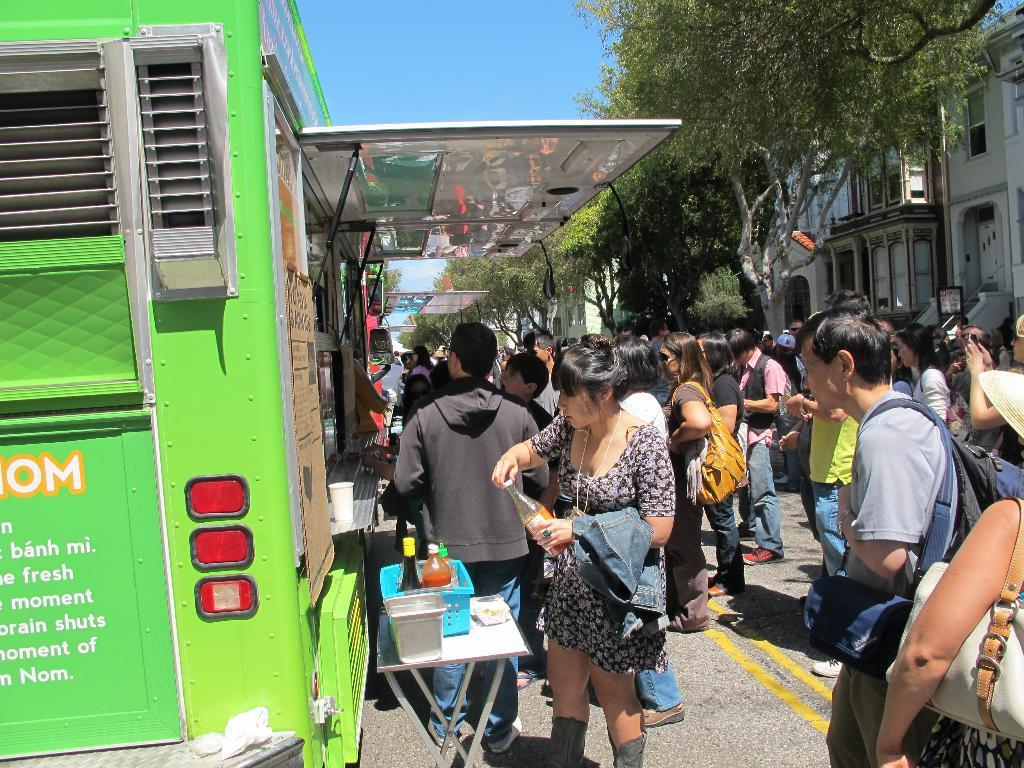What are the people in the image doing? The group of people in the image is standing on the road. What natural element can be seen in the image? There is a tree in the image. What type of structure is visible in the image? There is a building in the image. What is visible in the background of the image? The sky is visible in the image. Can you tell me how many quinces are hanging from the tree in the image? There are no quinces present in the image; it only features a tree and no fruit. How can the stranger join the group of people in the image? There is no stranger mentioned in the image, so it is not possible to answer how they might join the group. 